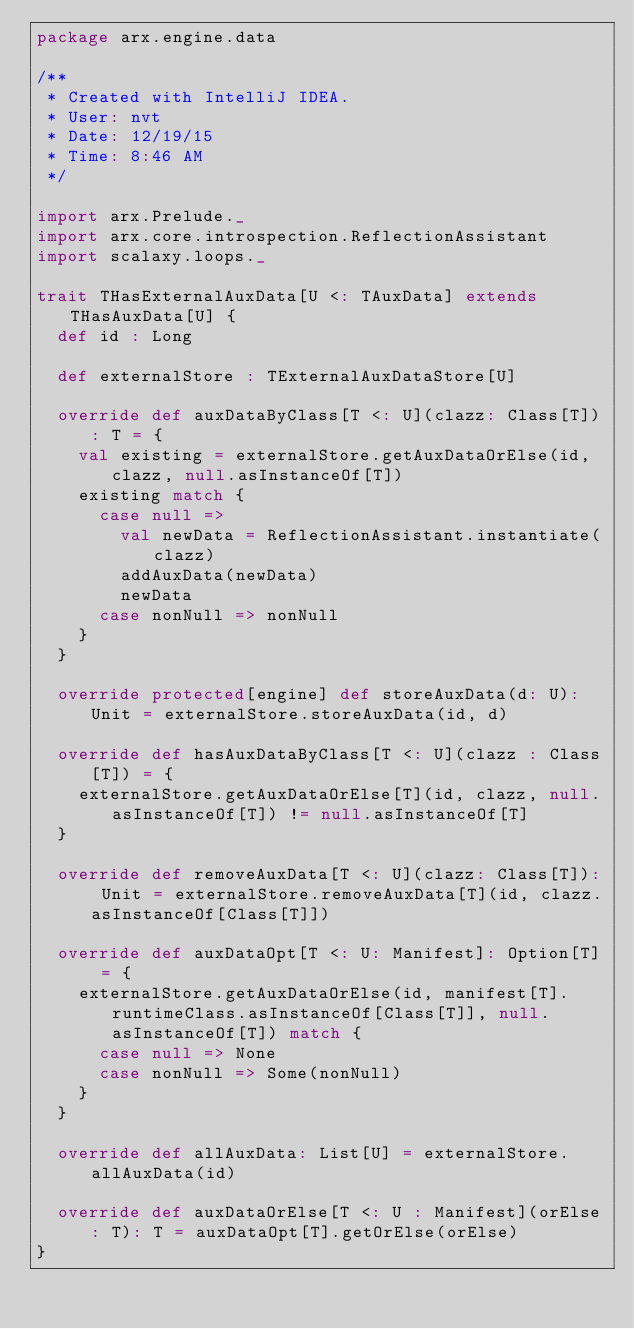<code> <loc_0><loc_0><loc_500><loc_500><_Scala_>package arx.engine.data

/**
 * Created with IntelliJ IDEA.
 * User: nvt
 * Date: 12/19/15
 * Time: 8:46 AM
 */

import arx.Prelude._
import arx.core.introspection.ReflectionAssistant
import scalaxy.loops._

trait THasExternalAuxData[U <: TAuxData] extends THasAuxData[U] {
	def id : Long

	def externalStore : TExternalAuxDataStore[U]

	override def auxDataByClass[T <: U](clazz: Class[T]): T = {
		val existing = externalStore.getAuxDataOrElse(id, clazz, null.asInstanceOf[T])
		existing match {
			case null =>
				val newData = ReflectionAssistant.instantiate(clazz)
				addAuxData(newData)
				newData
			case nonNull => nonNull
		}
	}

	override protected[engine] def storeAuxData(d: U): Unit = externalStore.storeAuxData(id, d)

	override def hasAuxDataByClass[T <: U](clazz : Class[T]) = {
		externalStore.getAuxDataOrElse[T](id, clazz, null.asInstanceOf[T]) != null.asInstanceOf[T]
	}

	override def removeAuxData[T <: U](clazz: Class[T]): Unit = externalStore.removeAuxData[T](id, clazz.asInstanceOf[Class[T]])

	override def auxDataOpt[T <: U: Manifest]: Option[T] = {
		externalStore.getAuxDataOrElse(id, manifest[T].runtimeClass.asInstanceOf[Class[T]], null.asInstanceOf[T]) match {
			case null => None
			case nonNull => Some(nonNull)
		}
	}

	override def allAuxData: List[U] = externalStore.allAuxData(id)

	override def auxDataOrElse[T <: U : Manifest](orElse: T): T = auxDataOpt[T].getOrElse(orElse)
}

</code> 